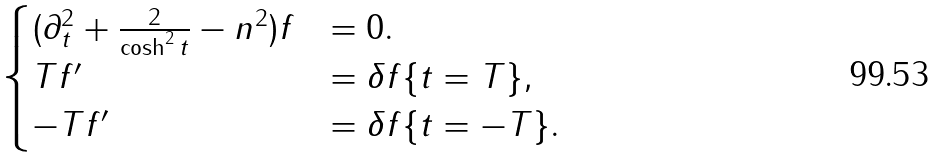Convert formula to latex. <formula><loc_0><loc_0><loc_500><loc_500>\begin{cases} ( \partial _ { t } ^ { 2 } + \frac { 2 } { \cosh ^ { 2 } { t } } - n ^ { 2 } ) f & = 0 . \\ T f ^ { \prime } & = \delta f \{ t = T \} , \\ - T f ^ { \prime } & = \delta f \{ t = - T \} . \end{cases}</formula> 